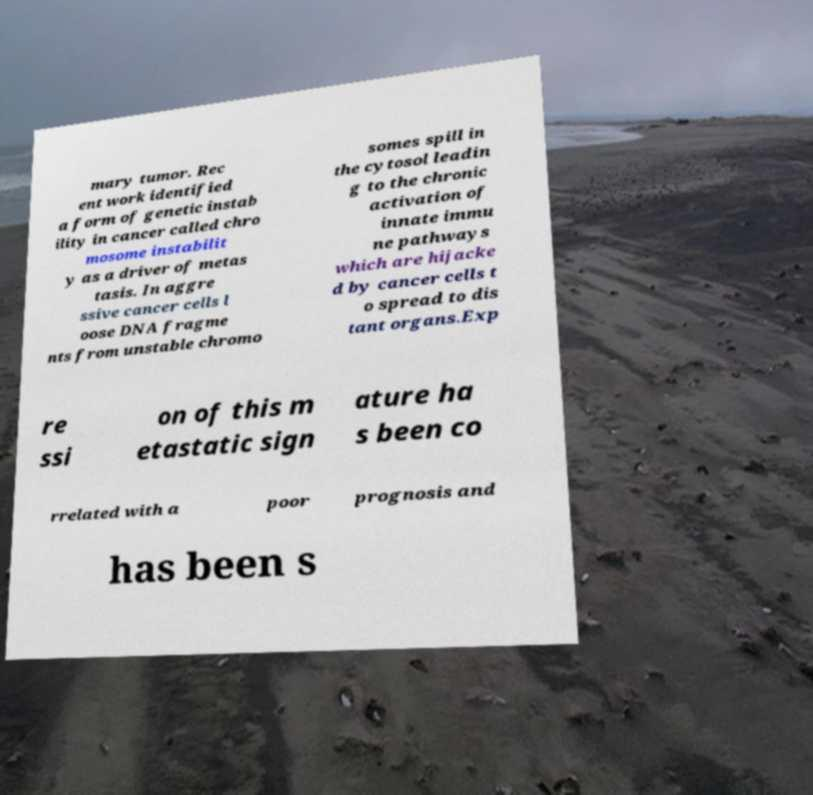I need the written content from this picture converted into text. Can you do that? mary tumor. Rec ent work identified a form of genetic instab ility in cancer called chro mosome instabilit y as a driver of metas tasis. In aggre ssive cancer cells l oose DNA fragme nts from unstable chromo somes spill in the cytosol leadin g to the chronic activation of innate immu ne pathways which are hijacke d by cancer cells t o spread to dis tant organs.Exp re ssi on of this m etastatic sign ature ha s been co rrelated with a poor prognosis and has been s 